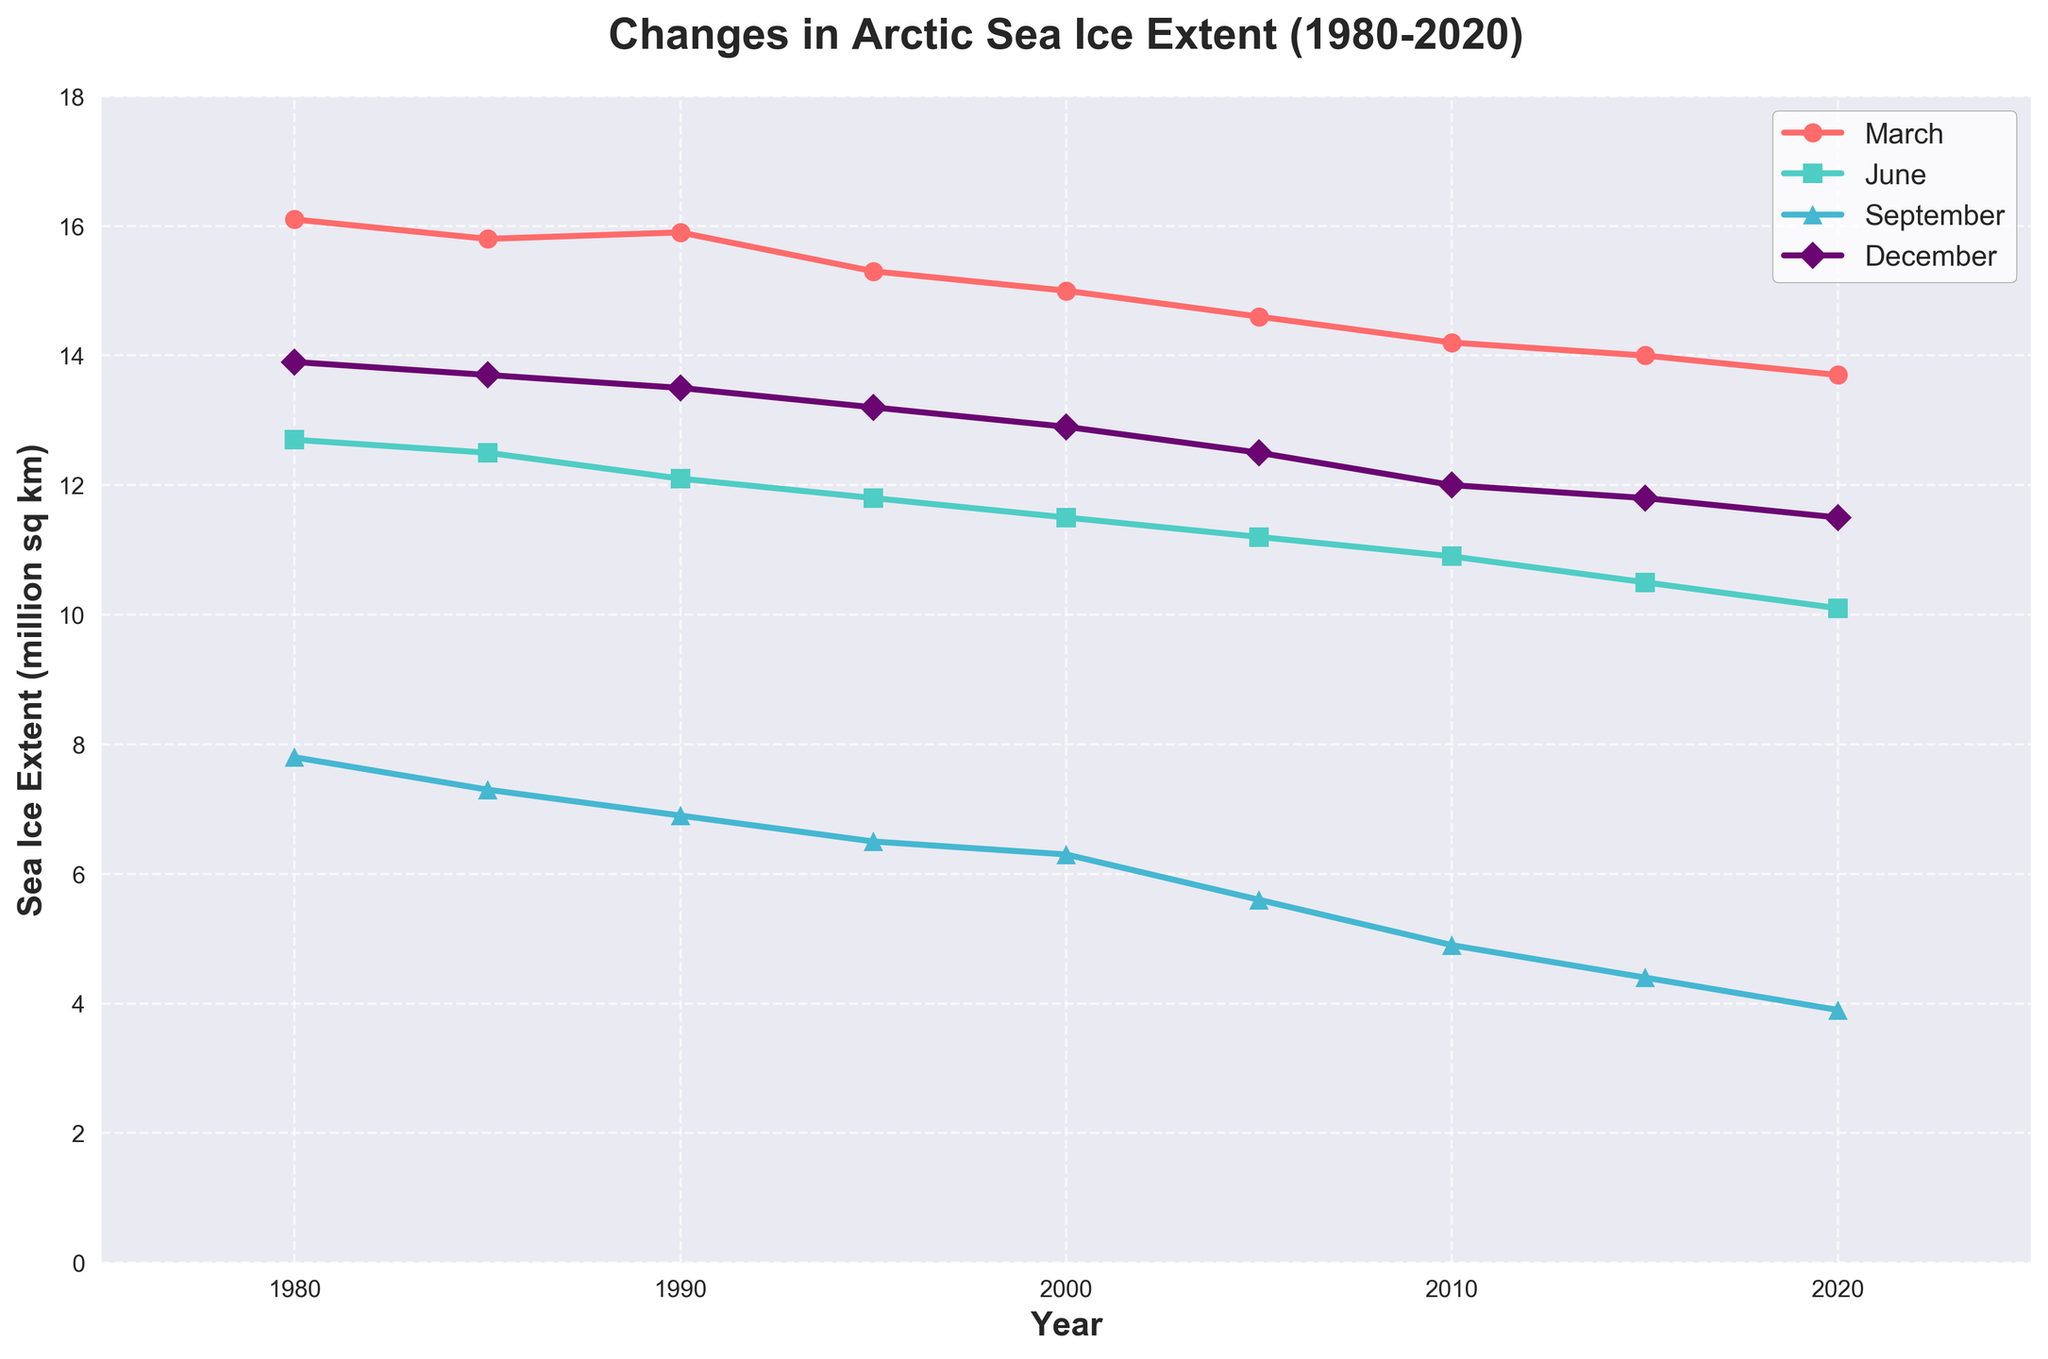What's the general trend for March sea ice extent from 1980 to 2020? The plot shows that the March sea ice extent generally decreases over the period from 1980 to 2020. Specifically, it goes from around 16.1 million sq km in 1980 to approximately 13.7 million sq km in 2020.
Answer: Decreasing Which month shows the largest reduction in sea ice extent from 1980 to 2020? By comparing the size of the visual reduction for all months, September shows the largest reduction, going from 7.8 million sq km in 1980 to 3.9 million sq km in 2020.
Answer: September In which year do both March sea ice extent and September sea ice extent have the same value? Examine the lines for March and September. No year shows the same value for March and September sea ice extent, hence there is no intersection point on the graph for these two months.
Answer: None What is the difference between the sea ice extent in December of 1980 and 2020? From the plot, December sea ice extent in 1980 is 13.9 million sq km and in 2020 is 11.5 million sq km. The difference is 13.9 - 11.5 = 2.4 million sq km.
Answer: 2.4 million sq km Which month has the most stable sea ice extent in the given years? By observing the steepness and uniformity of all lines, it is clear that December shows the least steep slopes, denoting relatively stable sea ice extent over time.
Answer: December What is the average sea ice extent for June between 2000 and 2020? Identify the ice extents for June in 2000, 2005, 2010, 2015, and 2020: (11.5 + 11.2 + 10.9 + 10.5 + 10.1) / 5 = 54.2 / 5 = 10.84 million sq km.
Answer: 10.84 million sq km When comparing March and June, which month shows a greater decrease in sea ice extent from 1980 to 2020? For March, the decrease is from 16.1 million sq km in 1980 to 13.7 million sq km in 2020, a 2.4 million sq km drop. For June, it goes from 12.7 million sq km in 1980 to 10.1 million sq km in 2020, a 2.6 million sq km drop. June shows a greater decrease.
Answer: June What is the sea ice extent in September in 2010, and how does it compare to the value in 1980? The value in 2010 for September is 4.9 million sq km, and in 1980 it is 7.8 million sq km. The decrease is 7.8 - 4.9 = 2.9 million sq km.
Answer: 2.9 million sq km decrease Estimate the rate of decrease in sea ice extent per decade for June. For June, the extent decreases from 12.7 million sq km in 1980 to 10.1 million sq km in 2020. The total decrease is 12.7 - 10.1 = 2.6 million sq km. Over 40 years, the rate per decade is 2.6 / 4 = 0.65 million sq km per decade.
Answer: 0.65 million sq km per decade 